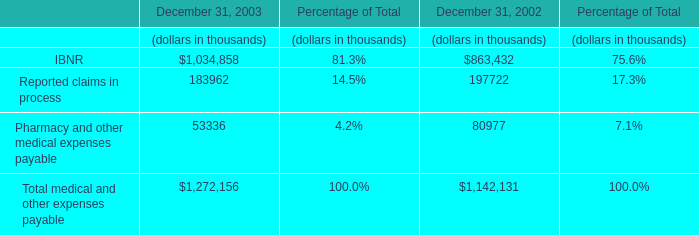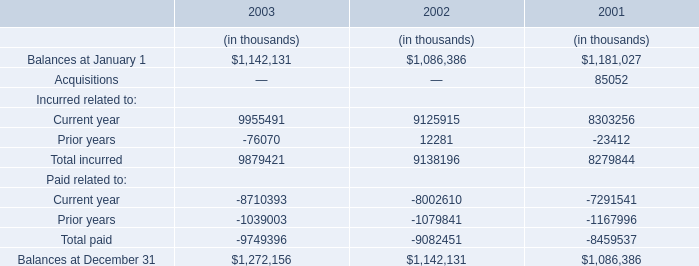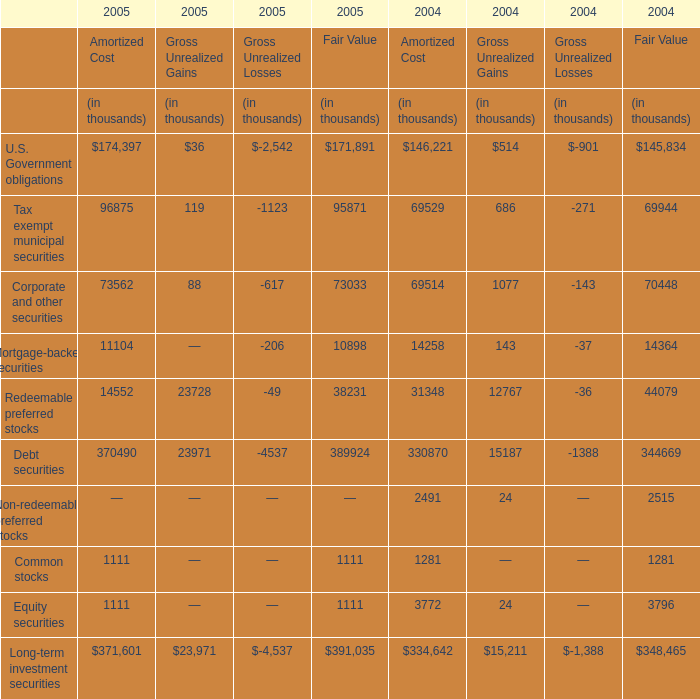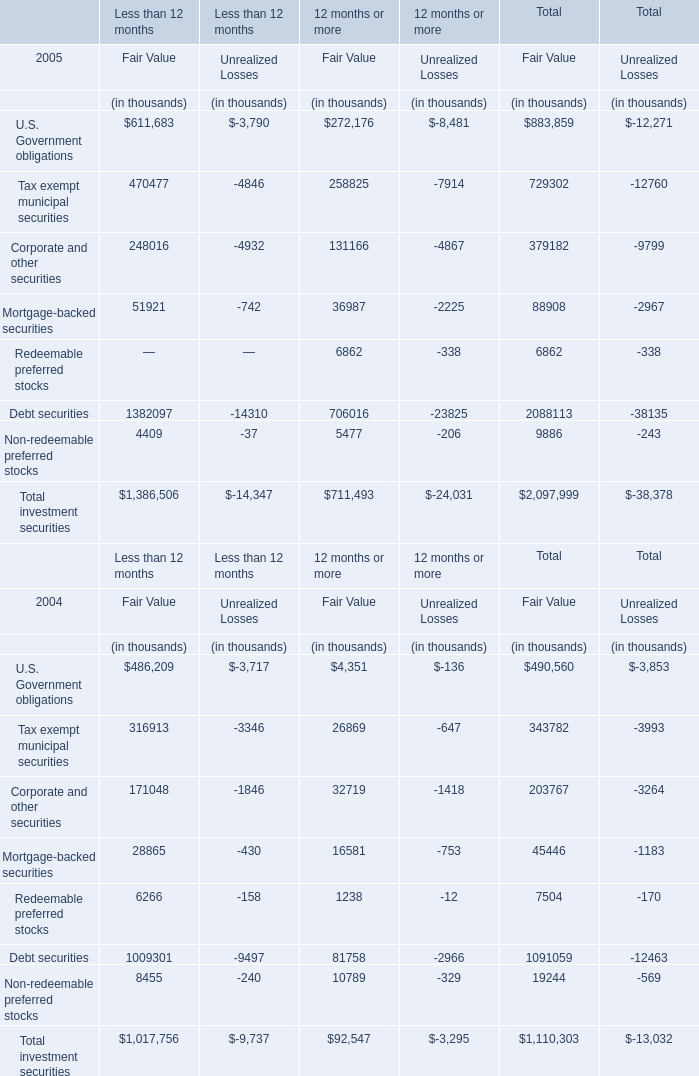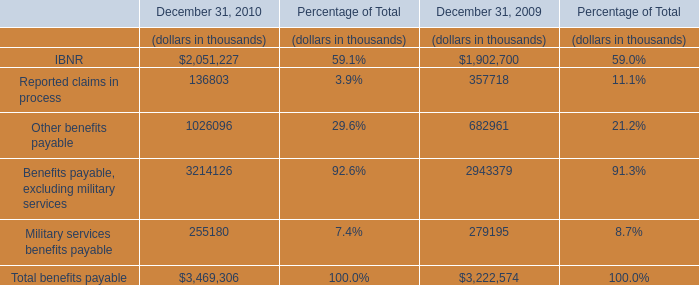What will U.S. Government obligations for Fair Value of Total be like in 2006 if it develops with the same increasing rate as current? (in thousand) 
Computations: (883859 * (1 + ((883859 - 490560) / 490560)))
Answer: 1592479.47627. 